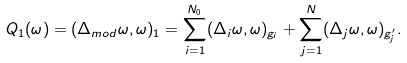<formula> <loc_0><loc_0><loc_500><loc_500>Q _ { 1 } ( \omega ) = ( \Delta _ { m o d } \omega , \omega ) _ { 1 } = \sum _ { i = 1 } ^ { N _ { 0 } } ( \Delta _ { i } \omega , \omega ) _ { g _ { i } } + \sum _ { j = 1 } ^ { N } ( \Delta _ { j } \omega , \omega ) _ { g ^ { \prime } _ { j } } .</formula> 